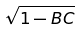<formula> <loc_0><loc_0><loc_500><loc_500>\sqrt { 1 - B C }</formula> 